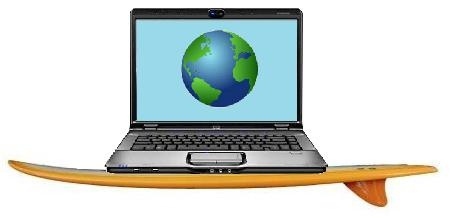Describe the objects in this image and their specific colors. I can see laptop in white, lightblue, black, gray, and lightgray tones and surfboard in white, orange, and red tones in this image. 